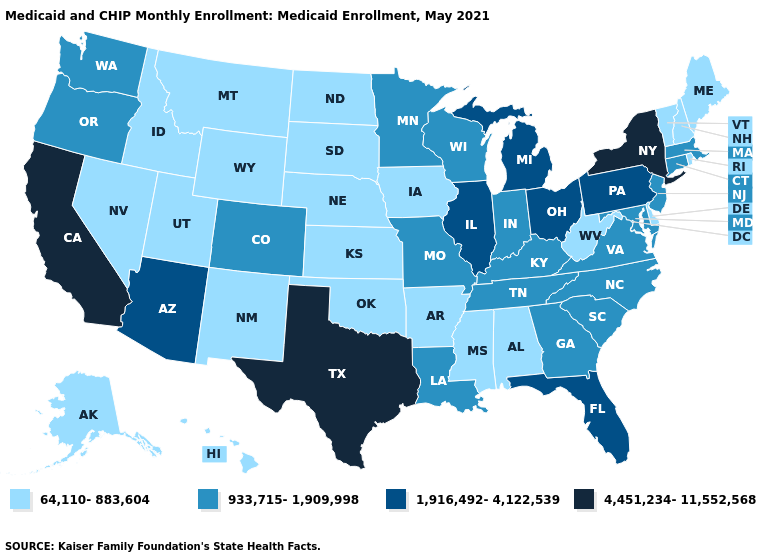Name the states that have a value in the range 1,916,492-4,122,539?
Short answer required. Arizona, Florida, Illinois, Michigan, Ohio, Pennsylvania. What is the lowest value in the USA?
Keep it brief. 64,110-883,604. Does California have the highest value in the USA?
Short answer required. Yes. Does New Hampshire have a lower value than Washington?
Be succinct. Yes. What is the value of Massachusetts?
Write a very short answer. 933,715-1,909,998. Name the states that have a value in the range 933,715-1,909,998?
Be succinct. Colorado, Connecticut, Georgia, Indiana, Kentucky, Louisiana, Maryland, Massachusetts, Minnesota, Missouri, New Jersey, North Carolina, Oregon, South Carolina, Tennessee, Virginia, Washington, Wisconsin. Name the states that have a value in the range 4,451,234-11,552,568?
Give a very brief answer. California, New York, Texas. What is the value of South Carolina?
Answer briefly. 933,715-1,909,998. What is the value of Rhode Island?
Be succinct. 64,110-883,604. Does New York have a higher value than California?
Write a very short answer. No. Is the legend a continuous bar?
Keep it brief. No. What is the value of Idaho?
Short answer required. 64,110-883,604. What is the value of North Carolina?
Concise answer only. 933,715-1,909,998. Name the states that have a value in the range 4,451,234-11,552,568?
Answer briefly. California, New York, Texas. What is the highest value in the West ?
Short answer required. 4,451,234-11,552,568. 